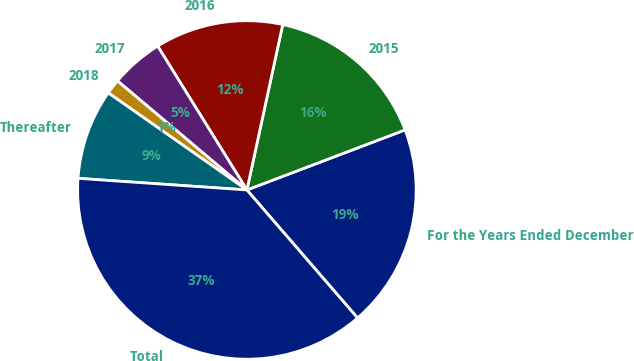Convert chart to OTSL. <chart><loc_0><loc_0><loc_500><loc_500><pie_chart><fcel>For the Years Ended December<fcel>2015<fcel>2016<fcel>2017<fcel>2018<fcel>Thereafter<fcel>Total<nl><fcel>19.43%<fcel>15.83%<fcel>12.23%<fcel>5.02%<fcel>1.42%<fcel>8.63%<fcel>37.44%<nl></chart> 